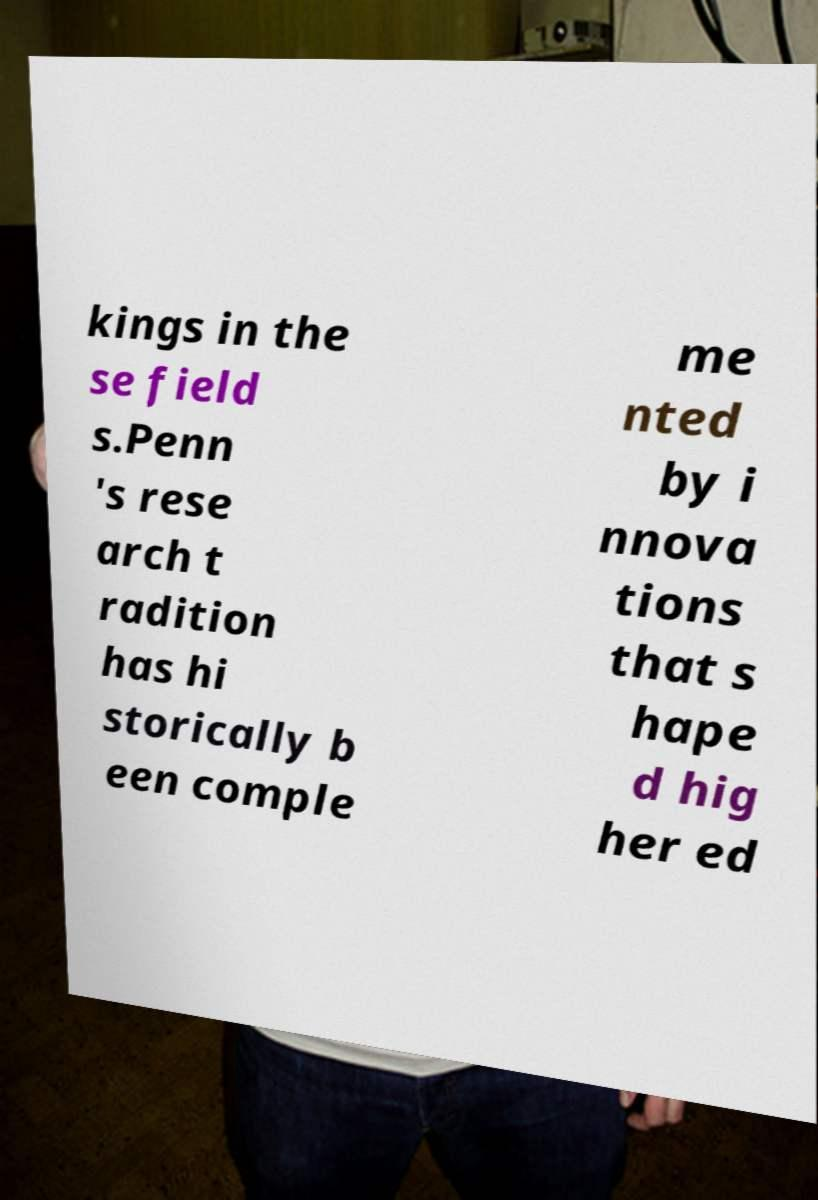There's text embedded in this image that I need extracted. Can you transcribe it verbatim? kings in the se field s.Penn 's rese arch t radition has hi storically b een comple me nted by i nnova tions that s hape d hig her ed 